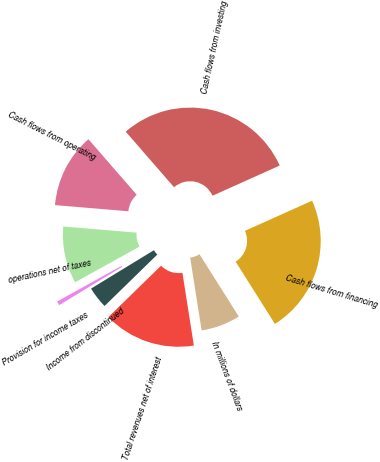Convert chart. <chart><loc_0><loc_0><loc_500><loc_500><pie_chart><fcel>In millions of dollars<fcel>Total revenues net of interest<fcel>Income from discontinued<fcel>Provision for income taxes<fcel>operations net of taxes<fcel>Cash flows from operating<fcel>Cash flows from investing<fcel>Cash flows from financing<nl><fcel>6.48%<fcel>15.18%<fcel>3.58%<fcel>0.68%<fcel>9.38%<fcel>12.28%<fcel>29.67%<fcel>22.76%<nl></chart> 